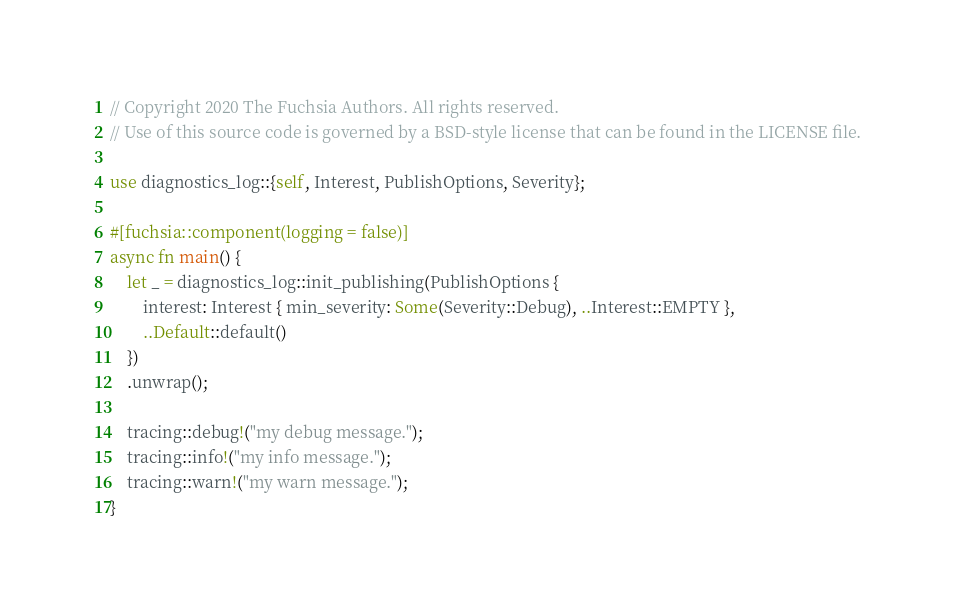<code> <loc_0><loc_0><loc_500><loc_500><_Rust_>// Copyright 2020 The Fuchsia Authors. All rights reserved.
// Use of this source code is governed by a BSD-style license that can be found in the LICENSE file.

use diagnostics_log::{self, Interest, PublishOptions, Severity};

#[fuchsia::component(logging = false)]
async fn main() {
    let _ = diagnostics_log::init_publishing(PublishOptions {
        interest: Interest { min_severity: Some(Severity::Debug), ..Interest::EMPTY },
        ..Default::default()
    })
    .unwrap();

    tracing::debug!("my debug message.");
    tracing::info!("my info message.");
    tracing::warn!("my warn message.");
}
</code> 